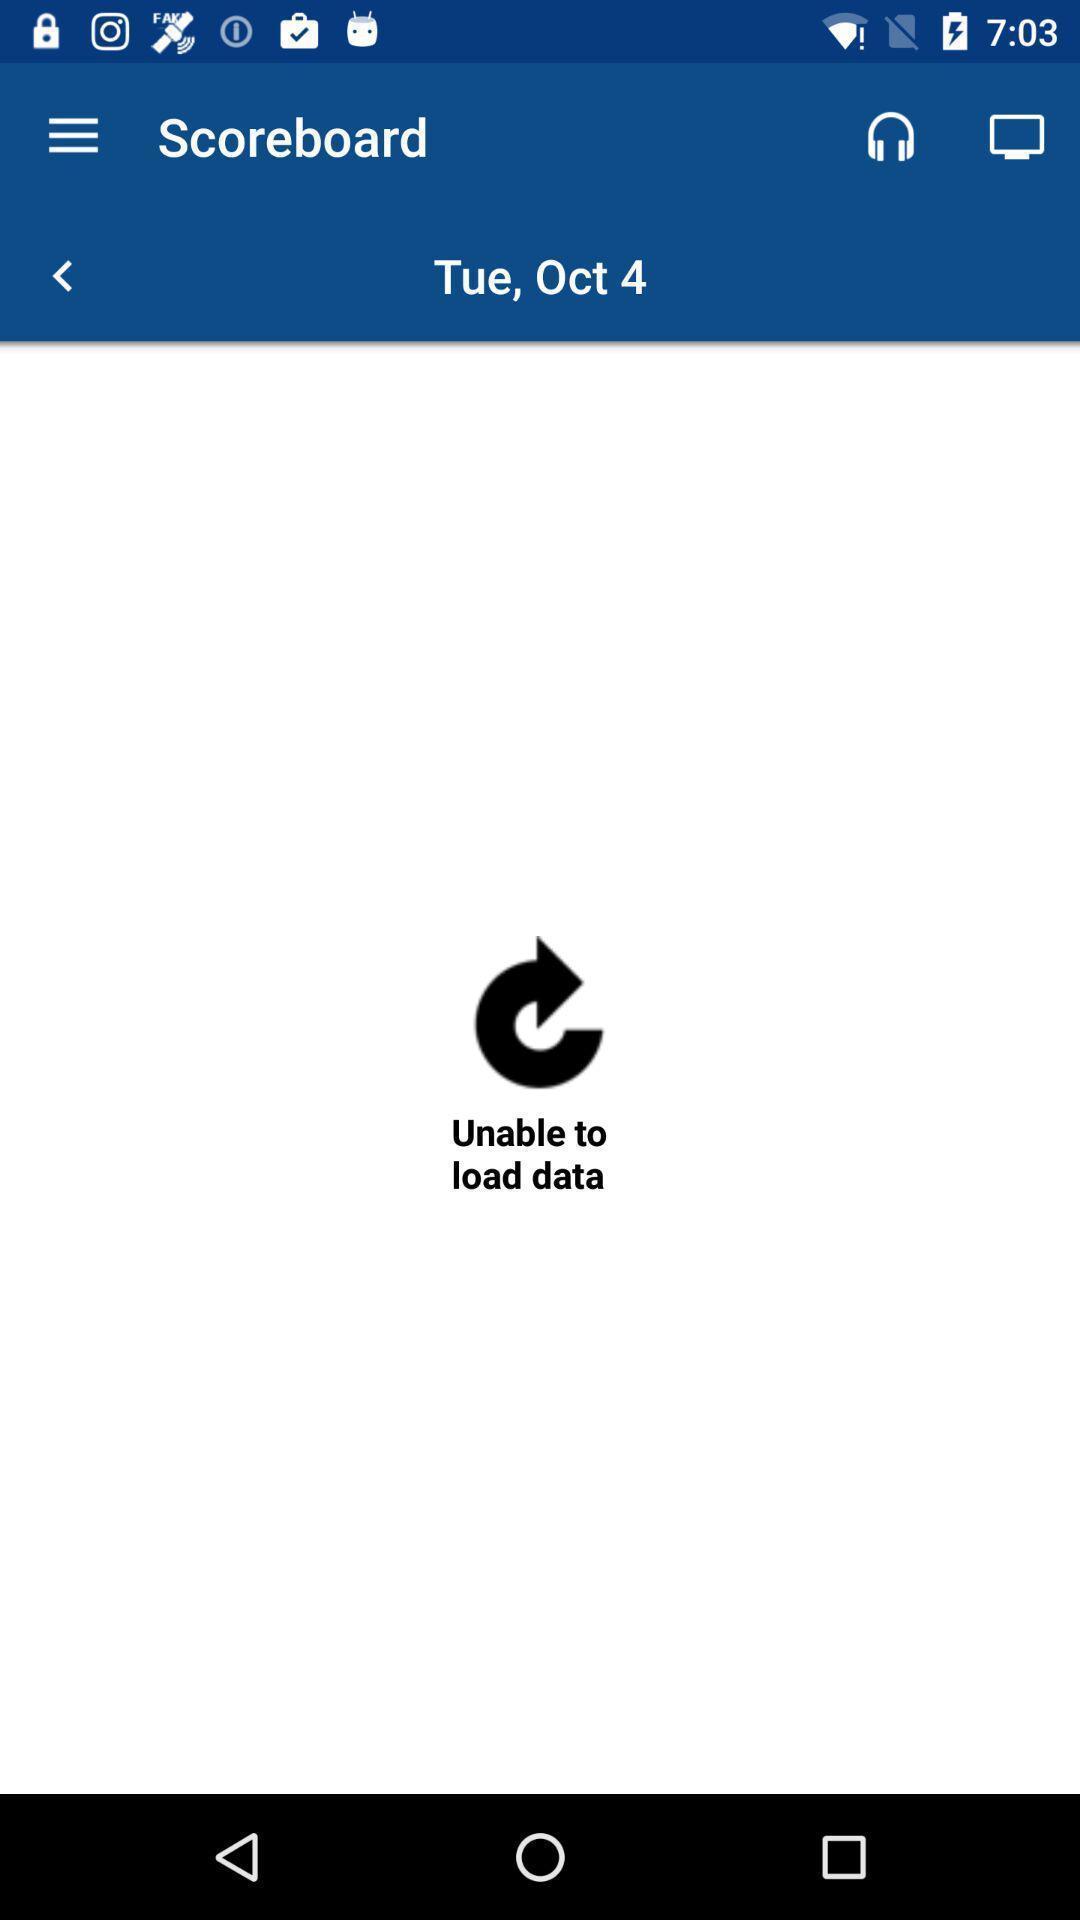What can you discern from this picture? Page showing scoreboard option. 